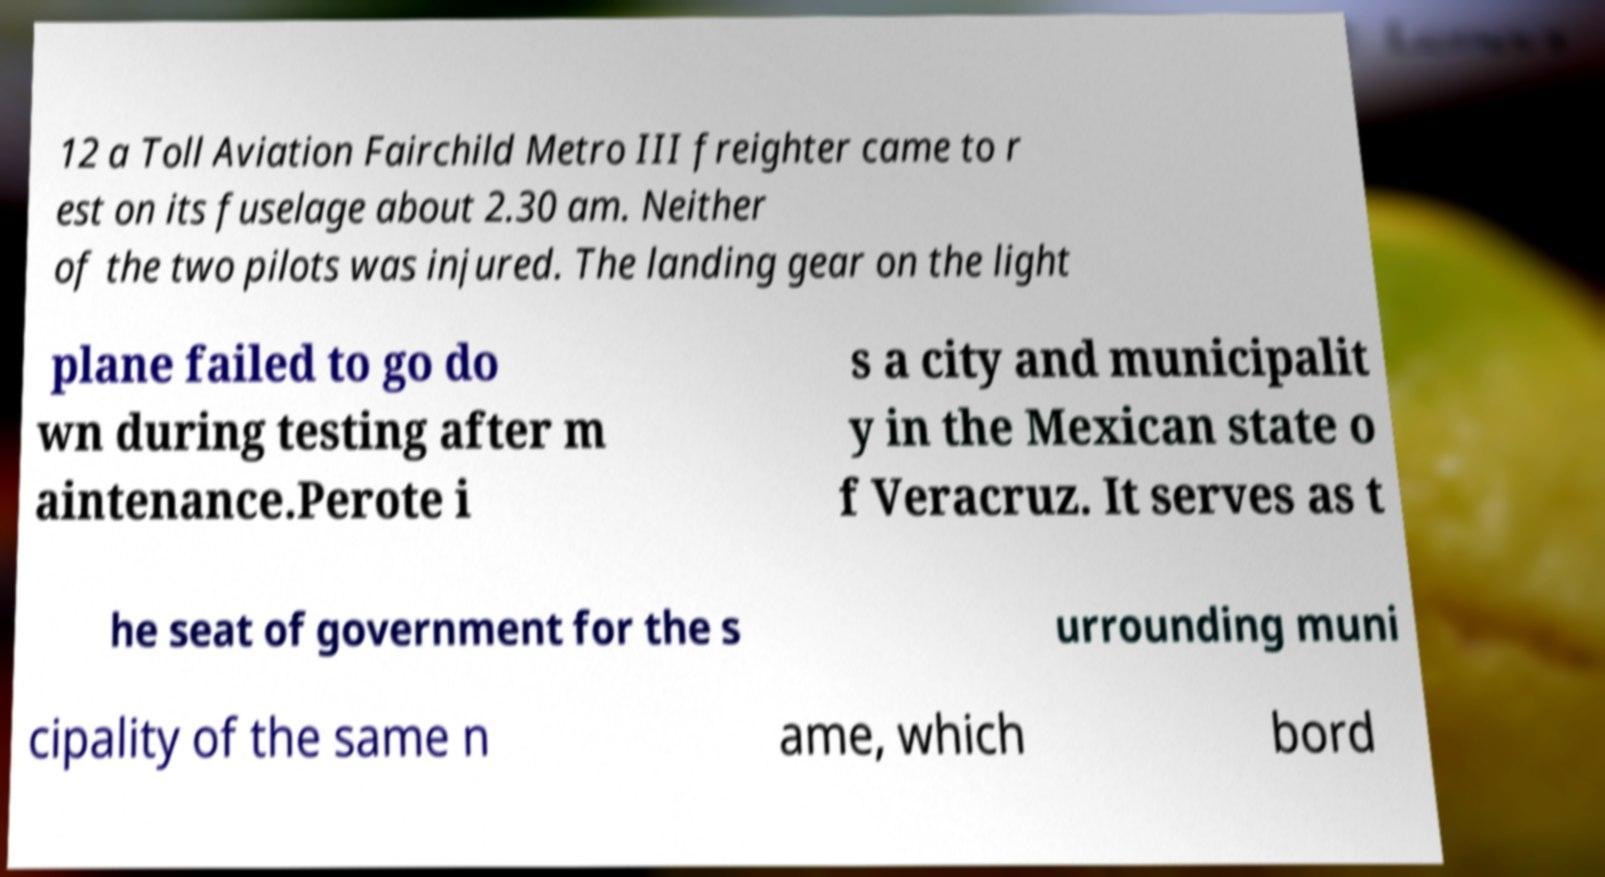Please read and relay the text visible in this image. What does it say? 12 a Toll Aviation Fairchild Metro III freighter came to r est on its fuselage about 2.30 am. Neither of the two pilots was injured. The landing gear on the light plane failed to go do wn during testing after m aintenance.Perote i s a city and municipalit y in the Mexican state o f Veracruz. It serves as t he seat of government for the s urrounding muni cipality of the same n ame, which bord 